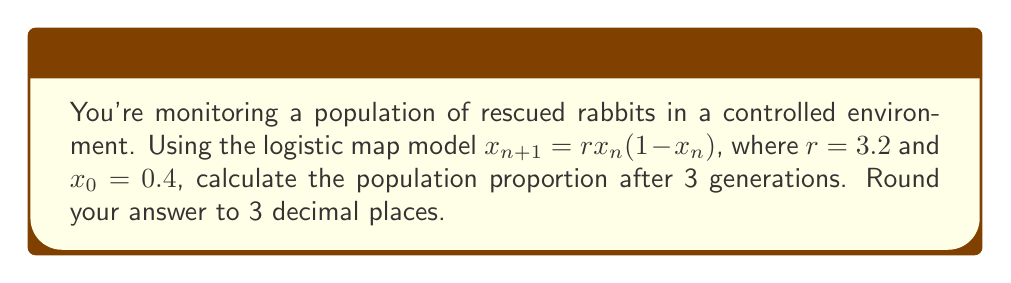Give your solution to this math problem. Let's apply the logistic map equation iteratively:

1) For the first generation ($n=0$ to $n=1$):
   $x_1 = 3.2 \cdot 0.4 \cdot (1-0.4)$
   $x_1 = 3.2 \cdot 0.4 \cdot 0.6 = 0.768$

2) For the second generation ($n=1$ to $n=2$):
   $x_2 = 3.2 \cdot 0.768 \cdot (1-0.768)$
   $x_2 = 3.2 \cdot 0.768 \cdot 0.232 = 0.570982$

3) For the third generation ($n=2$ to $n=3$):
   $x_3 = 3.2 \cdot 0.570982 \cdot (1-0.570982)$
   $x_3 = 3.2 \cdot 0.570982 \cdot 0.429018 = 0.784497$

4) Rounding to 3 decimal places:
   $x_3 \approx 0.784$

This final value represents the proportion of the maximum possible population after 3 generations.
Answer: 0.784 